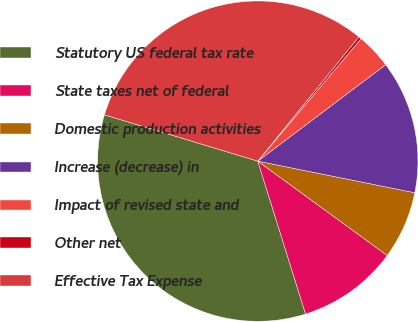Convert chart to OTSL. <chart><loc_0><loc_0><loc_500><loc_500><pie_chart><fcel>Statutory US federal tax rate<fcel>State taxes net of federal<fcel>Domestic production activities<fcel>Increase (decrease) in<fcel>Impact of revised state and<fcel>Other net<fcel>Effective Tax Expense<nl><fcel>34.48%<fcel>10.15%<fcel>6.86%<fcel>13.44%<fcel>3.57%<fcel>0.28%<fcel>31.19%<nl></chart> 